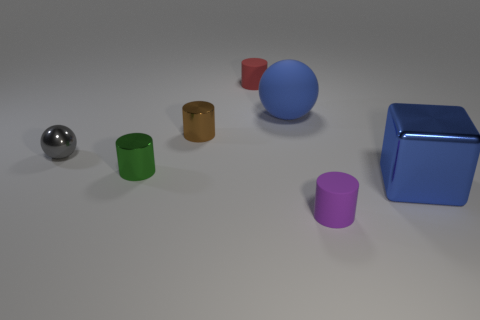How many big balls have the same color as the cube?
Your response must be concise. 1. What material is the tiny purple cylinder?
Your answer should be very brief. Rubber. Do the object that is right of the purple thing and the rubber ball have the same color?
Provide a succinct answer. Yes. Is there anything else that is the same shape as the big metallic object?
Your answer should be compact. No. What is the color of the other shiny thing that is the same shape as the brown metal thing?
Your answer should be very brief. Green. What material is the big object that is left of the big metallic block?
Offer a very short reply. Rubber. The small metal sphere is what color?
Make the answer very short. Gray. There is a matte cylinder that is in front of the blue metal thing; does it have the same size as the large blue shiny cube?
Your answer should be very brief. No. What is the small thing in front of the large thing that is to the right of the big blue object that is to the left of the cube made of?
Give a very brief answer. Rubber. Does the metal object that is on the right side of the large blue sphere have the same color as the big thing behind the brown shiny thing?
Your response must be concise. Yes. 